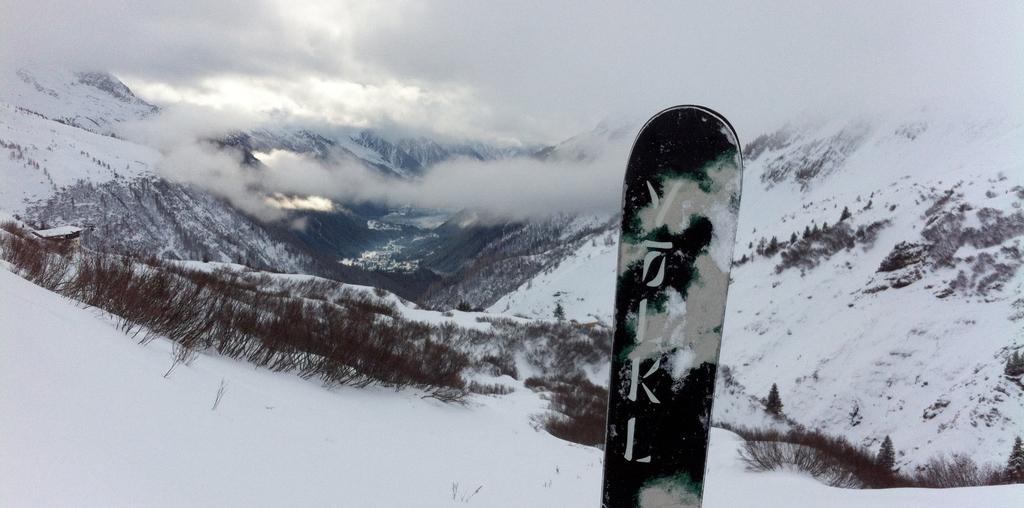Could you give a brief overview of what you see in this image? This picture is taken in a snow hill. In the center, there is a board. In the background, there are hills covered with the snow, plants and fog. 